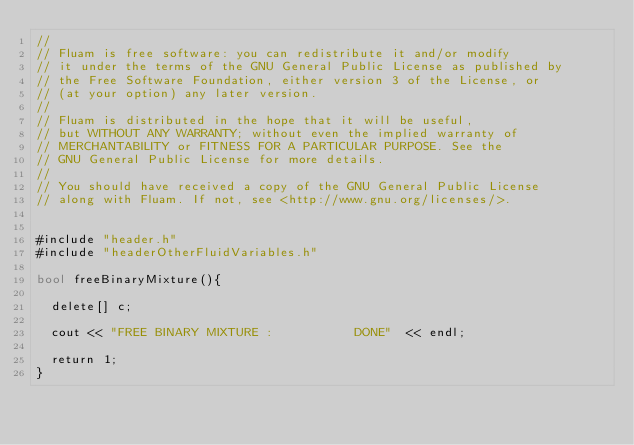Convert code to text. <code><loc_0><loc_0><loc_500><loc_500><_Cuda_>//
// Fluam is free software: you can redistribute it and/or modify
// it under the terms of the GNU General Public License as published by
// the Free Software Foundation, either version 3 of the License, or
// (at your option) any later version.
//
// Fluam is distributed in the hope that it will be useful,
// but WITHOUT ANY WARRANTY; without even the implied warranty of
// MERCHANTABILITY or FITNESS FOR A PARTICULAR PURPOSE. See the
// GNU General Public License for more details.
//
// You should have received a copy of the GNU General Public License
// along with Fluam. If not, see <http://www.gnu.org/licenses/>.


#include "header.h"
#include "headerOtherFluidVariables.h"

bool freeBinaryMixture(){
   
  delete[] c;

  cout << "FREE BINARY MIXTURE :           DONE"  << endl;

  return 1;
}

</code> 